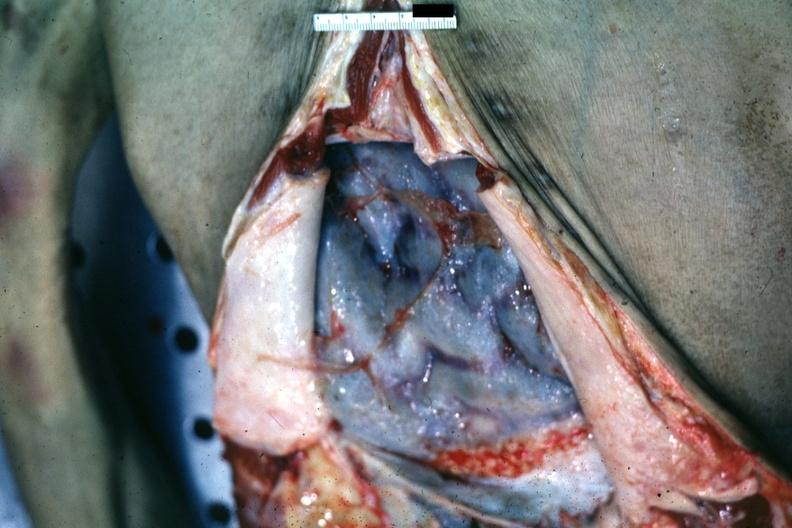what is present?
Answer the question using a single word or phrase. Abdomen 